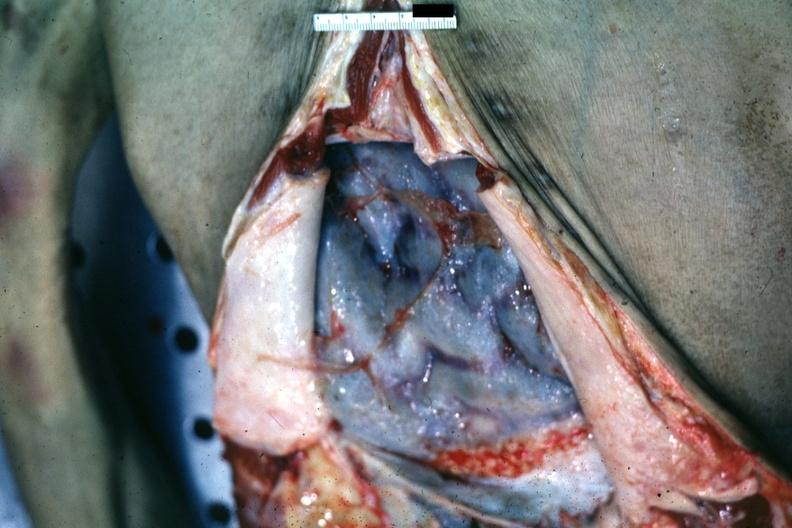what is present?
Answer the question using a single word or phrase. Abdomen 